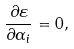<formula> <loc_0><loc_0><loc_500><loc_500>\frac { \partial \varepsilon } { \partial \alpha _ { i } } = 0 ,</formula> 